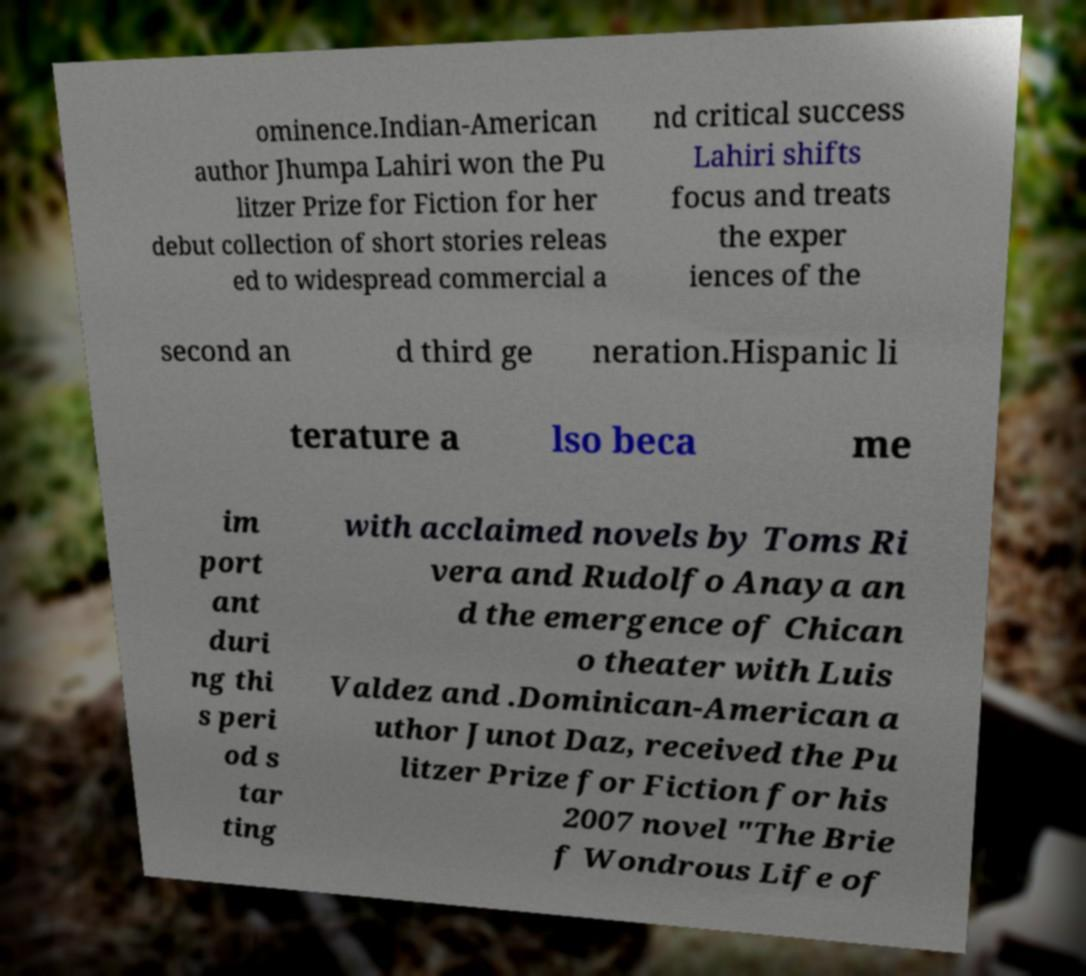Could you extract and type out the text from this image? ominence.Indian-American author Jhumpa Lahiri won the Pu litzer Prize for Fiction for her debut collection of short stories releas ed to widespread commercial a nd critical success Lahiri shifts focus and treats the exper iences of the second an d third ge neration.Hispanic li terature a lso beca me im port ant duri ng thi s peri od s tar ting with acclaimed novels by Toms Ri vera and Rudolfo Anaya an d the emergence of Chican o theater with Luis Valdez and .Dominican-American a uthor Junot Daz, received the Pu litzer Prize for Fiction for his 2007 novel "The Brie f Wondrous Life of 